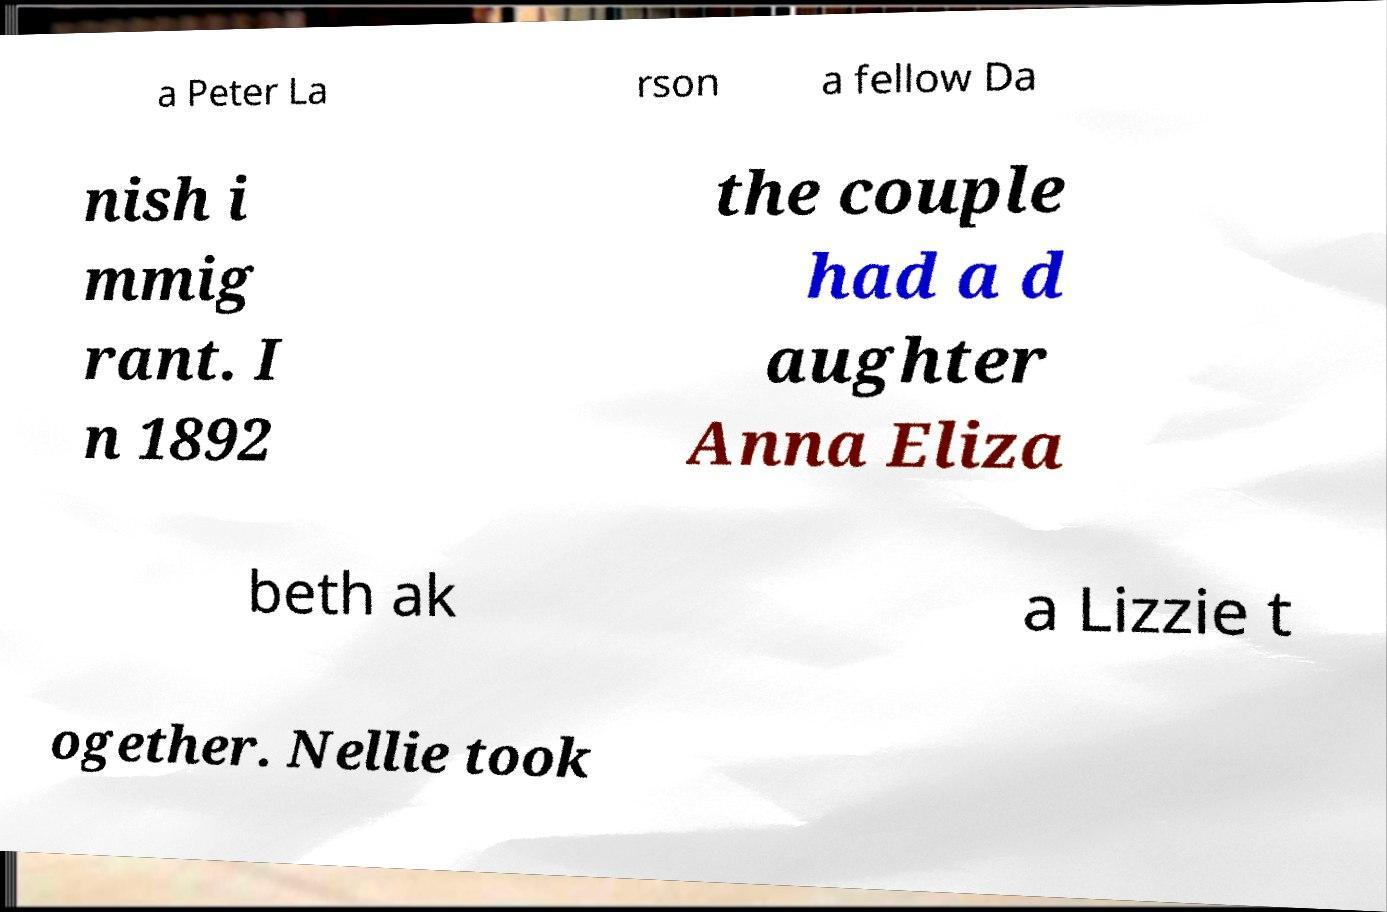Could you assist in decoding the text presented in this image and type it out clearly? a Peter La rson a fellow Da nish i mmig rant. I n 1892 the couple had a d aughter Anna Eliza beth ak a Lizzie t ogether. Nellie took 